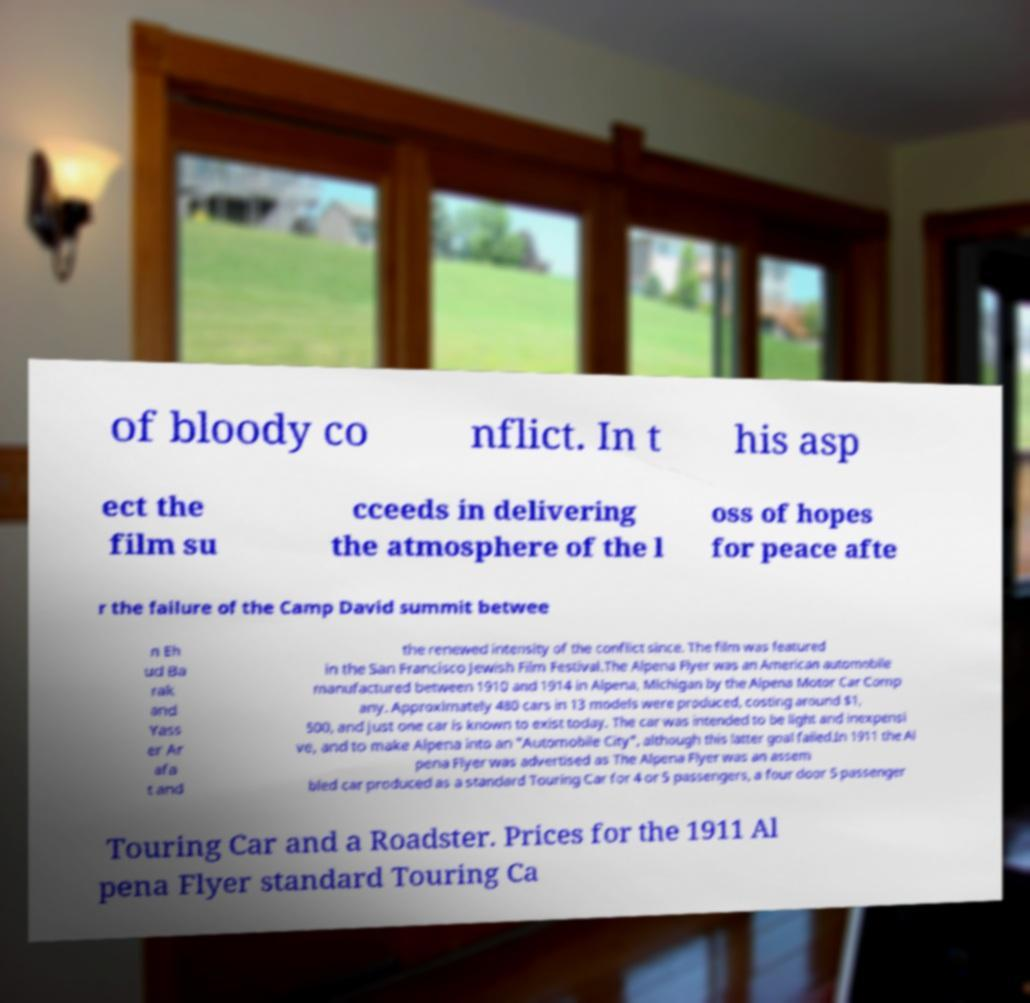Could you assist in decoding the text presented in this image and type it out clearly? of bloody co nflict. In t his asp ect the film su cceeds in delivering the atmosphere of the l oss of hopes for peace afte r the failure of the Camp David summit betwee n Eh ud Ba rak and Yass er Ar afa t and the renewed intensity of the conflict since. The film was featured in the San Francisco Jewish Film Festival.The Alpena Flyer was an American automobile manufactured between 1910 and 1914 in Alpena, Michigan by the Alpena Motor Car Comp any. Approximately 480 cars in 13 models were produced, costing around $1, 500, and just one car is known to exist today. The car was intended to be light and inexpensi ve, and to make Alpena into an "Automobile City", although this latter goal failed.In 1911 the Al pena Flyer was advertised as The Alpena Flyer was an assem bled car produced as a standard Touring Car for 4 or 5 passengers, a four door 5 passenger Touring Car and a Roadster. Prices for the 1911 Al pena Flyer standard Touring Ca 